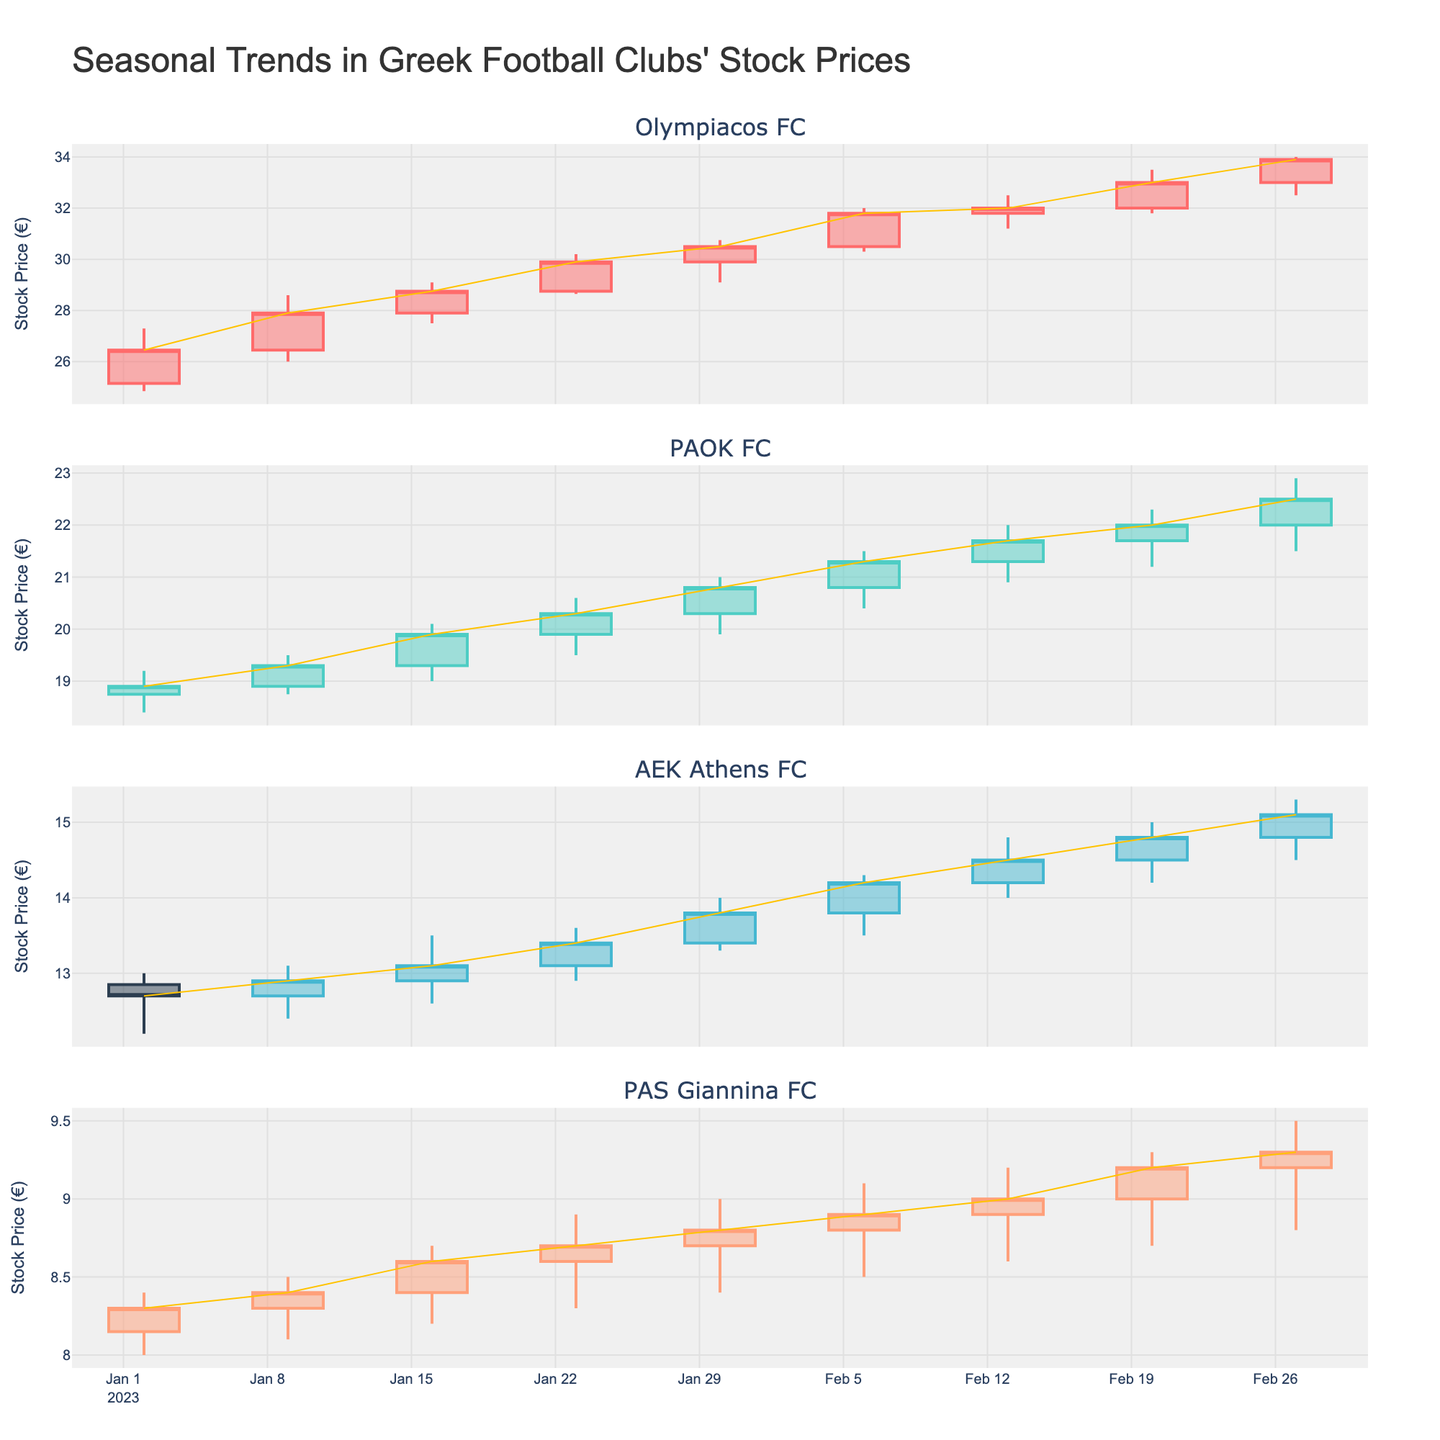Which football club has the highest stock closing price on January 2, 2023? We need to look at the stock closing prices of all clubs on January 2, 2023. Olympiacos FC has 26.45, PAOK FC has 18.90, AEK Athens FC has 12.70, and PAS Giannina FC has 8.30. The highest price is 26.45 for Olympiacos FC.
Answer: Olympiacos FC What is the overall trend of PAOK FC's stock price from January to February? By observing the line connecting the closing prices for PAOK FC from January to February, we see a gradual upwards movement from the initial to the final data points. This shows an uptrend.
Answer: Uptrend Between which dates did Olympiacos FC's stock price experience the largest weekly increase? To find this, we need to look at the differences in closing prices week by week. The largest weekly increase for Olympiacos FC is from February 20 (33.00) to February 27 (33.90), which is an increase of 0.90.
Answer: February 20 to February 27 Which club had the least volatile stock performance during the period shown? Volatility can be assessed by the range of high and low prices. PAS Giannina FC has the smallest difference between the high and low prices across all weeks, indicating the least volatility.
Answer: PAS Giannina FC How did the closing prices of AEK Athens FC and PAS Giannina FC compare on February 27, 2023? For February 27, compare the closing prices: AEK Athens FC closes at 15.10 and PAS Giannina FC at 9.30. AEK Athens FC's closing price is higher than PAS Giannina FC's.
Answer: AEK Athens FC higher What is the average stock closing price for AEK Athens FC in January 2023? The closing prices for AEK Athens FC in January are: 12.70, 12.90, 13.10, 13.40, and 13.80. We sum these (12.70 + 12.90 + 13.10 + 13.40 + 13.80) = 66.90 and divide by 5, yielding 13.38.
Answer: 13.38 Between PAOK FC and Olympiacos FC, which club had a higher stock closing price on February 6, 2023? On February 6, the closing price for PAOK FC was 21.30, while for Olympiacos FC it was 31.80. Olympiacos FC had the higher stock closing price.
Answer: Olympiacos FC What was the stock price difference between the highest and lowest points for PAS Giannina FC during the given period? The highest price for PAS Giannina FC was 9.50 (February 27) and the lowest was 8.00 (January 2). The difference is 9.50 - 8.00 = 1.50.
Answer: 1.50 